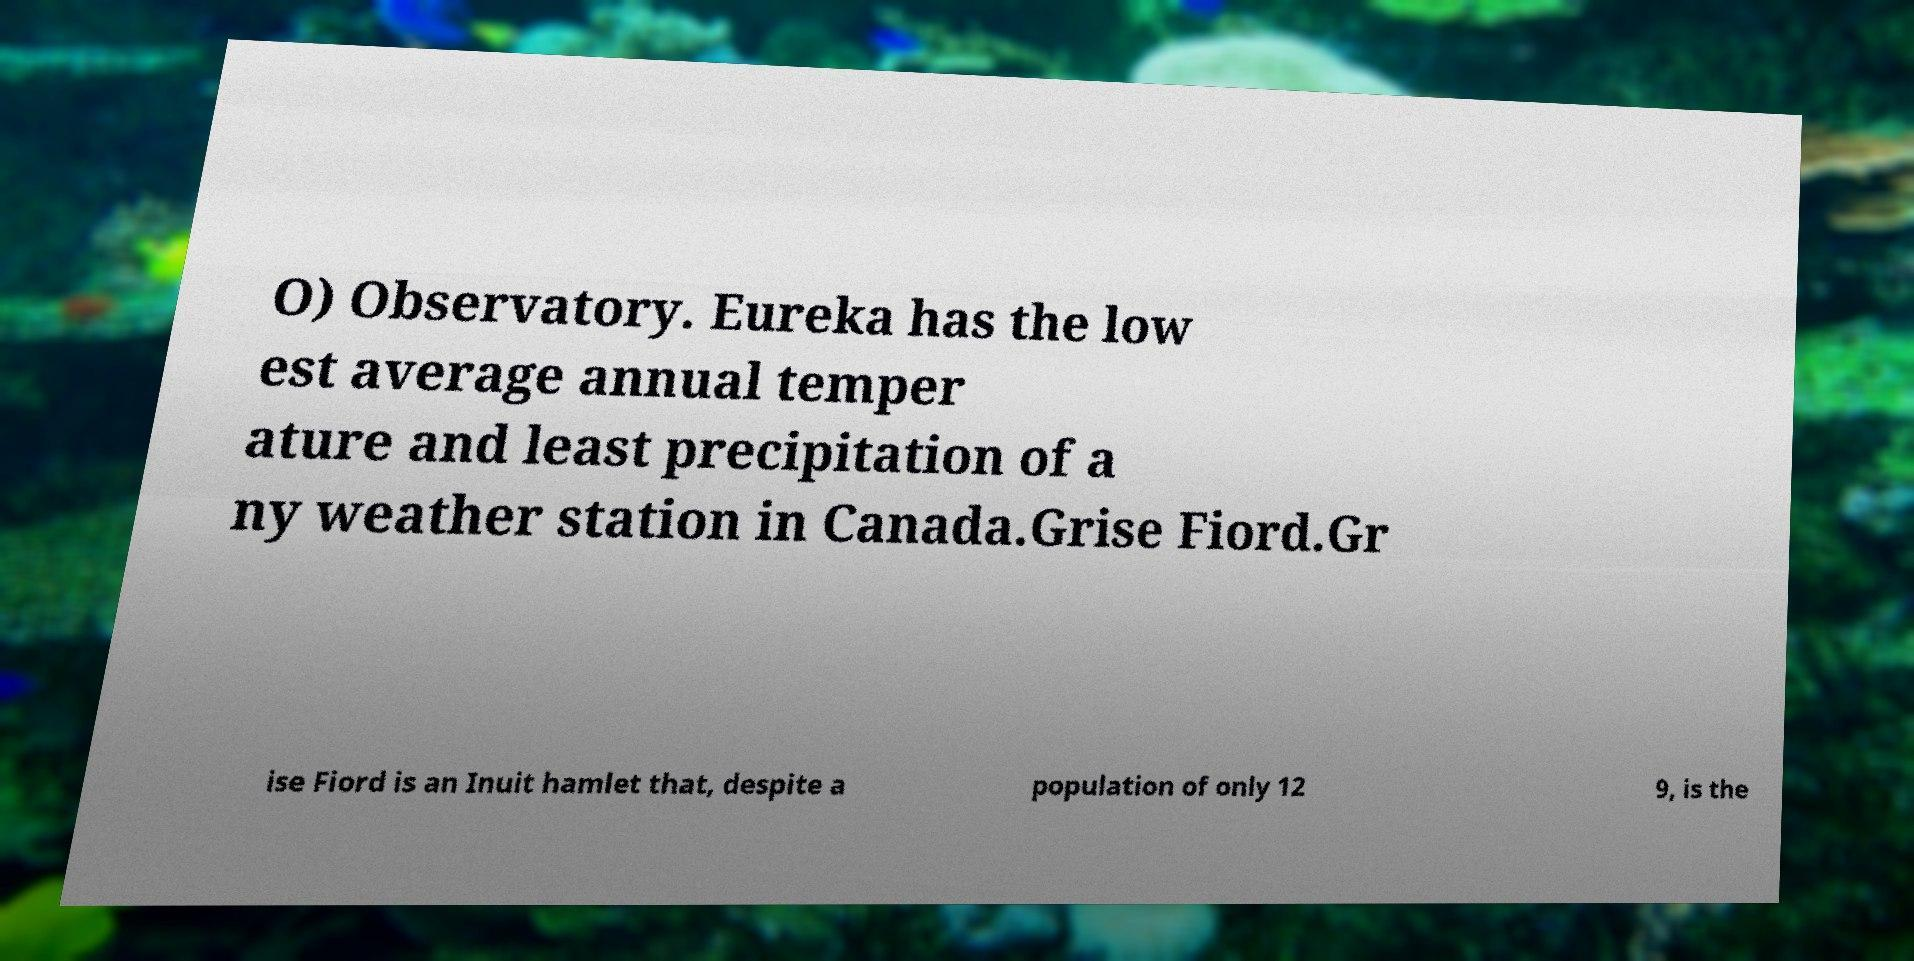I need the written content from this picture converted into text. Can you do that? O) Observatory. Eureka has the low est average annual temper ature and least precipitation of a ny weather station in Canada.Grise Fiord.Gr ise Fiord is an Inuit hamlet that, despite a population of only 12 9, is the 